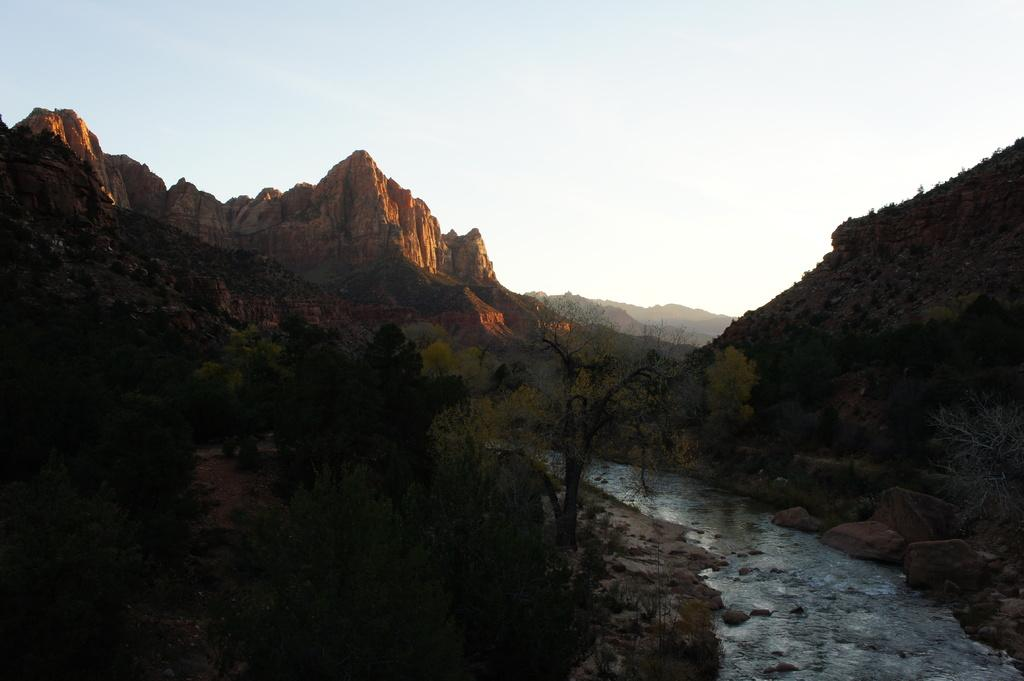What is visible in the image? Water, trees, and mountains are visible in the image. What can be seen in the background of the image? The sky is visible in the background of the image. What type of natural environment is depicted in the image? The image features a combination of water, trees, and mountains, which suggests a natural landscape. What is the weight of the society depicted in the image? There is no society present in the image, so it is not possible to determine its weight. 